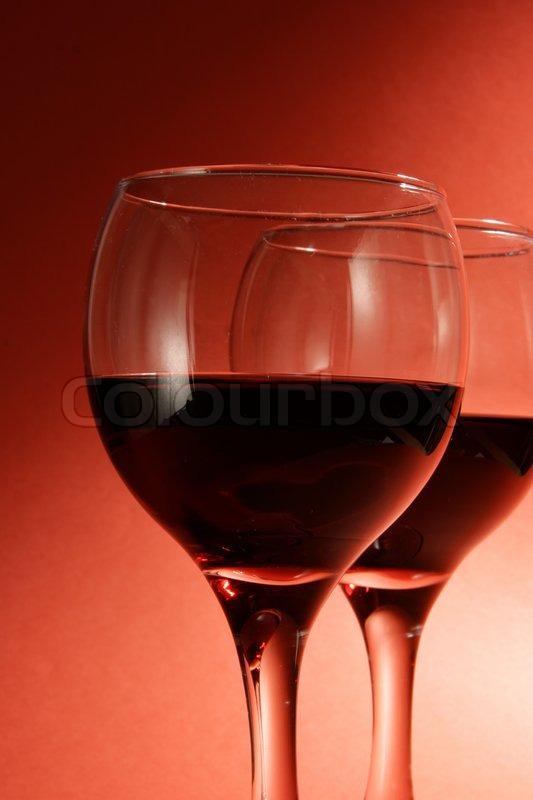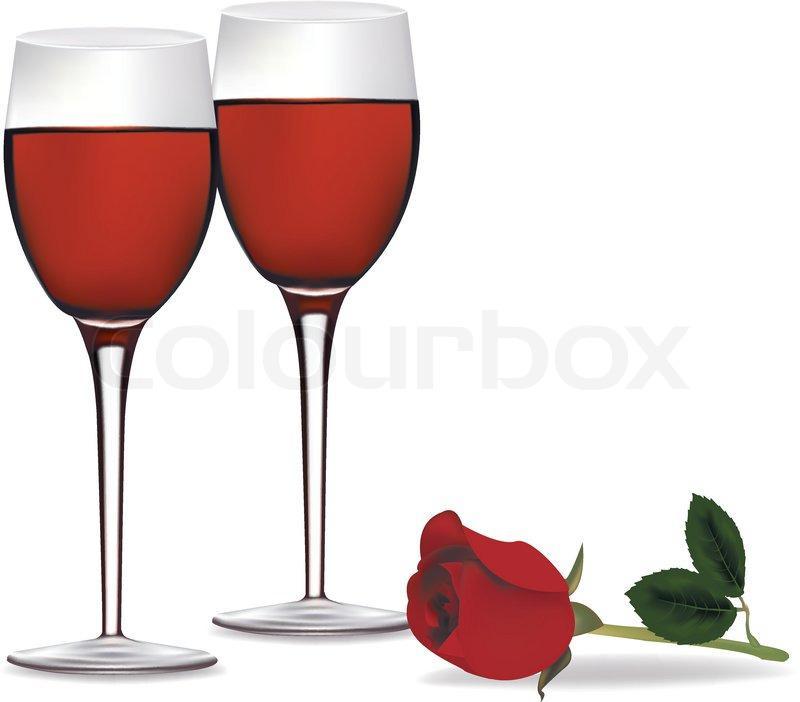The first image is the image on the left, the second image is the image on the right. Given the left and right images, does the statement "One image shows two glasses of red wine clinking together with wine spilling out and the other image shows only two still glasses of red wine side by side" hold true? Answer yes or no. No. The first image is the image on the left, the second image is the image on the right. Evaluate the accuracy of this statement regarding the images: "Each image contains two wine glasses and no bottles, and left image shows red wine splashing from glasses clinked together.". Is it true? Answer yes or no. No. 